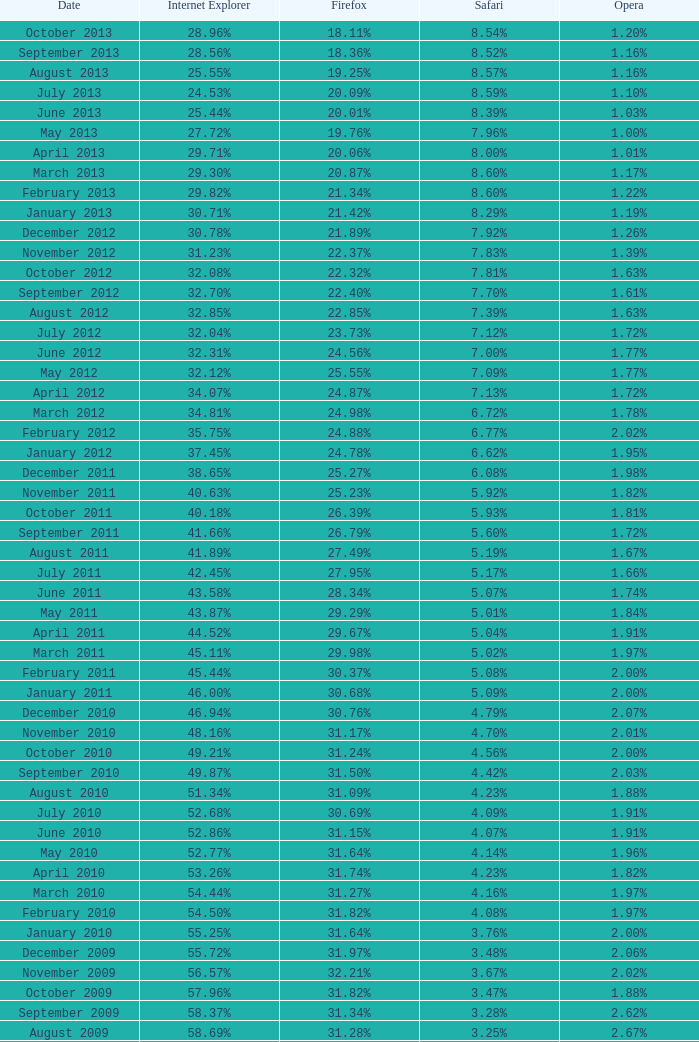During the time when firefox had a 31.27% usage rate, what was the percentage of safari users? 4.16%. Help me parse the entirety of this table. {'header': ['Date', 'Internet Explorer', 'Firefox', 'Safari', 'Opera'], 'rows': [['October 2013', '28.96%', '18.11%', '8.54%', '1.20%'], ['September 2013', '28.56%', '18.36%', '8.52%', '1.16%'], ['August 2013', '25.55%', '19.25%', '8.57%', '1.16%'], ['July 2013', '24.53%', '20.09%', '8.59%', '1.10%'], ['June 2013', '25.44%', '20.01%', '8.39%', '1.03%'], ['May 2013', '27.72%', '19.76%', '7.96%', '1.00%'], ['April 2013', '29.71%', '20.06%', '8.00%', '1.01%'], ['March 2013', '29.30%', '20.87%', '8.60%', '1.17%'], ['February 2013', '29.82%', '21.34%', '8.60%', '1.22%'], ['January 2013', '30.71%', '21.42%', '8.29%', '1.19%'], ['December 2012', '30.78%', '21.89%', '7.92%', '1.26%'], ['November 2012', '31.23%', '22.37%', '7.83%', '1.39%'], ['October 2012', '32.08%', '22.32%', '7.81%', '1.63%'], ['September 2012', '32.70%', '22.40%', '7.70%', '1.61%'], ['August 2012', '32.85%', '22.85%', '7.39%', '1.63%'], ['July 2012', '32.04%', '23.73%', '7.12%', '1.72%'], ['June 2012', '32.31%', '24.56%', '7.00%', '1.77%'], ['May 2012', '32.12%', '25.55%', '7.09%', '1.77%'], ['April 2012', '34.07%', '24.87%', '7.13%', '1.72%'], ['March 2012', '34.81%', '24.98%', '6.72%', '1.78%'], ['February 2012', '35.75%', '24.88%', '6.77%', '2.02%'], ['January 2012', '37.45%', '24.78%', '6.62%', '1.95%'], ['December 2011', '38.65%', '25.27%', '6.08%', '1.98%'], ['November 2011', '40.63%', '25.23%', '5.92%', '1.82%'], ['October 2011', '40.18%', '26.39%', '5.93%', '1.81%'], ['September 2011', '41.66%', '26.79%', '5.60%', '1.72%'], ['August 2011', '41.89%', '27.49%', '5.19%', '1.67%'], ['July 2011', '42.45%', '27.95%', '5.17%', '1.66%'], ['June 2011', '43.58%', '28.34%', '5.07%', '1.74%'], ['May 2011', '43.87%', '29.29%', '5.01%', '1.84%'], ['April 2011', '44.52%', '29.67%', '5.04%', '1.91%'], ['March 2011', '45.11%', '29.98%', '5.02%', '1.97%'], ['February 2011', '45.44%', '30.37%', '5.08%', '2.00%'], ['January 2011', '46.00%', '30.68%', '5.09%', '2.00%'], ['December 2010', '46.94%', '30.76%', '4.79%', '2.07%'], ['November 2010', '48.16%', '31.17%', '4.70%', '2.01%'], ['October 2010', '49.21%', '31.24%', '4.56%', '2.00%'], ['September 2010', '49.87%', '31.50%', '4.42%', '2.03%'], ['August 2010', '51.34%', '31.09%', '4.23%', '1.88%'], ['July 2010', '52.68%', '30.69%', '4.09%', '1.91%'], ['June 2010', '52.86%', '31.15%', '4.07%', '1.91%'], ['May 2010', '52.77%', '31.64%', '4.14%', '1.96%'], ['April 2010', '53.26%', '31.74%', '4.23%', '1.82%'], ['March 2010', '54.44%', '31.27%', '4.16%', '1.97%'], ['February 2010', '54.50%', '31.82%', '4.08%', '1.97%'], ['January 2010', '55.25%', '31.64%', '3.76%', '2.00%'], ['December 2009', '55.72%', '31.97%', '3.48%', '2.06%'], ['November 2009', '56.57%', '32.21%', '3.67%', '2.02%'], ['October 2009', '57.96%', '31.82%', '3.47%', '1.88%'], ['September 2009', '58.37%', '31.34%', '3.28%', '2.62%'], ['August 2009', '58.69%', '31.28%', '3.25%', '2.67%'], ['July 2009', '60.11%', '30.50%', '3.02%', '2.64%'], ['June 2009', '59.49%', '30.26%', '2.91%', '3.46%'], ['May 2009', '62.09%', '28.75%', '2.65%', '3.23%'], ['April 2009', '61.88%', '29.67%', '2.75%', '2.96%'], ['March 2009', '62.52%', '29.40%', '2.73%', '2.94%'], ['February 2009', '64.43%', '27.85%', '2.59%', '2.95%'], ['January 2009', '65.41%', '27.03%', '2.57%', '2.92%'], ['December 2008', '67.84%', '25.23%', '2.41%', '2.83%'], ['November 2008', '68.14%', '25.27%', '2.49%', '3.01%'], ['October 2008', '67.68%', '25.54%', '2.91%', '2.69%'], ['September2008', '67.16%', '25.77%', '3.00%', '2.86%'], ['August 2008', '68.91%', '26.08%', '2.99%', '1.83%'], ['July 2008', '68.57%', '26.14%', '3.30%', '1.78%']]} 